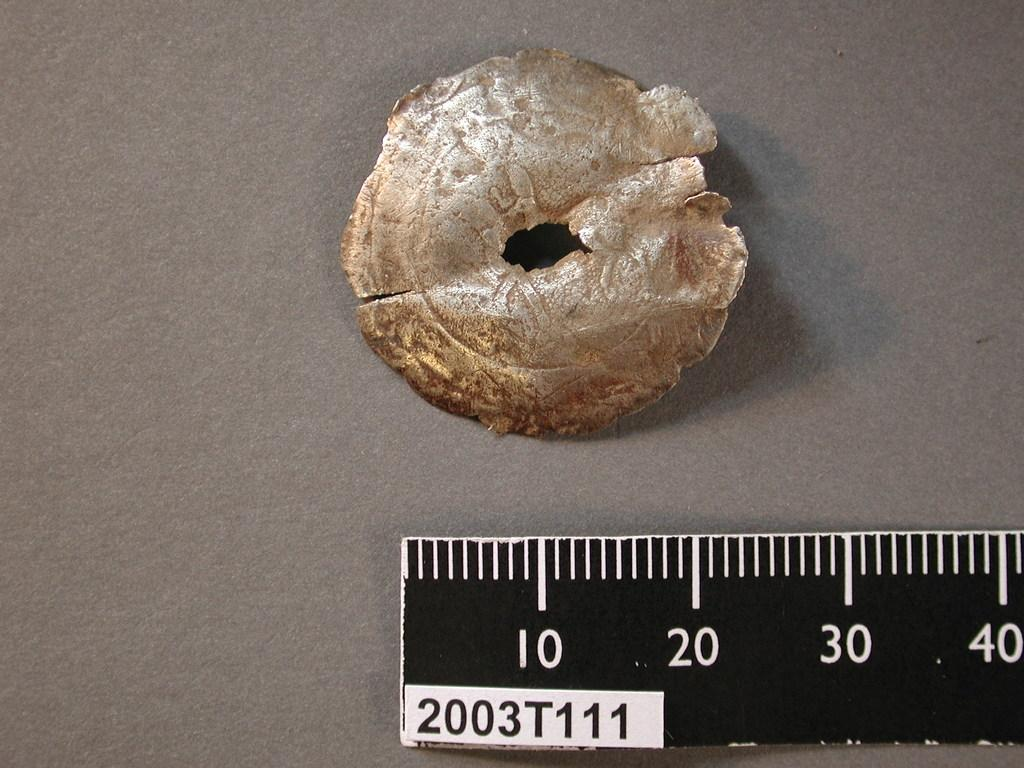Provide a one-sentence caption for the provided image. A piece of goldish cement in the shape of a cirlce with a small hole inside of the circle with a ruler underneath with the a label 2003T111. 